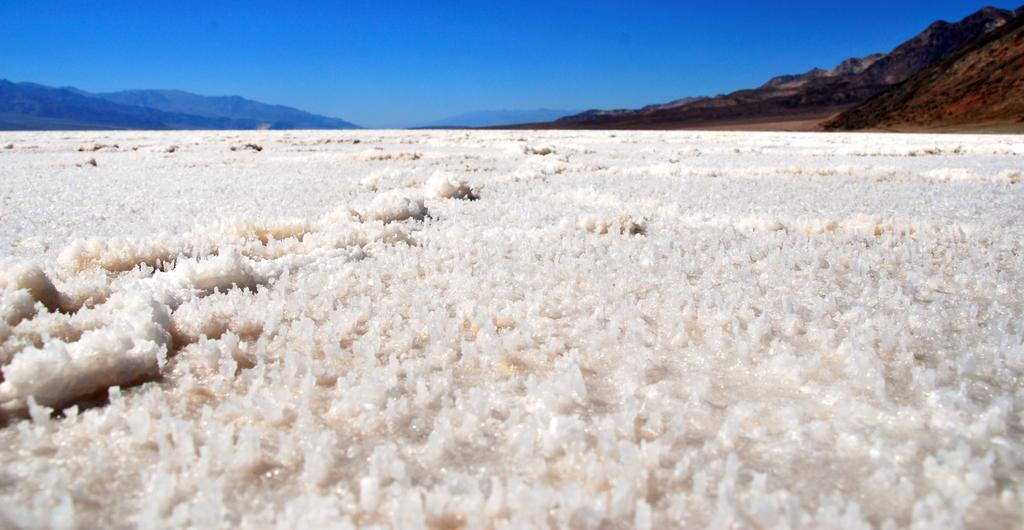What type of weather condition is depicted in the image? There is snow in the image, indicating a cold or wintry weather condition. Where is the snow located in the image? The snow is located at the bottom of the image. What other geographical features can be seen in the image? There are hills located on the right side of the image. What is the color of the sky in the image? The sky is blue in the image. Where is the blue sky visible in the image? The blue sky is visible at the top of the image. What type of basketball game is taking place in the middle of the image? There is no basketball game present in the image; it features snow, hills, and a blue sky. What type of disease can be seen affecting the trees in the image? There are no trees or diseases present in the image. 